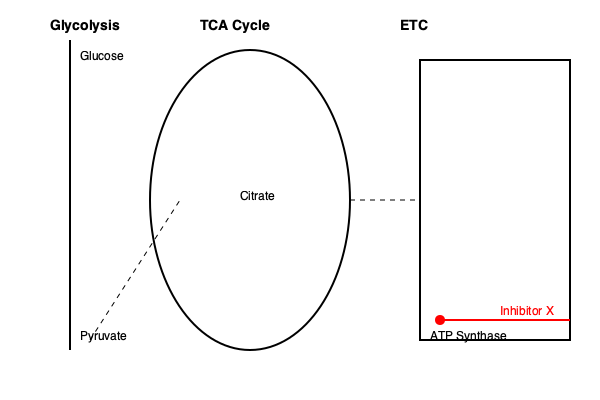In the metabolic pathway diagram, an inhibitor X is shown to affect a specific component. Given your expertise in disease mechanisms, explain how this inhibition might impact overall cellular energy production and propose a potential therapeutic strategy to counteract its effects. To understand the impact of inhibitor X and propose a therapeutic strategy, let's analyze the diagram step-by-step:

1. Pathway overview:
   - The diagram shows three main pathways: Glycolysis, TCA (Tricarboxylic Acid) Cycle, and ETC (Electron Transport Chain).
   - These pathways are interconnected and crucial for cellular energy production.

2. Inhibitor X's target:
   - The red line and circle indicate that inhibitor X is targeting ATP Synthase in the ETC.

3. Role of ATP Synthase:
   - ATP Synthase is the final enzyme complex in the ETC, responsible for synthesizing ATP through oxidative phosphorylation.
   - It utilizes the proton gradient generated by the ETC to produce ATP from ADP and inorganic phosphate.

4. Impact of inhibition:
   - Inhibiting ATP Synthase would significantly reduce ATP production through oxidative phosphorylation.
   - This would lead to a decrease in overall cellular energy production.
   - The proton gradient might build up excessively, potentially leading to mitochondrial dysfunction.

5. Cascade effects:
   - Reduced ATP production could affect various cellular processes dependent on ATP.
   - The TCA cycle might slow down due to feedback inhibition from accumulated NADH and FADH2.
   - Glycolysis might increase to compensate, leading to increased lactate production and potential acidosis.

6. Potential therapeutic strategies:
   a) Direct approach: Develop a competitive inhibitor that can displace inhibitor X from ATP Synthase.
   b) Bypass strategy: Enhance substrate-level phosphorylation in glycolysis and the TCA cycle to partially compensate for reduced oxidative phosphorylation.
   c) Alternative energy source: Introduce ketone bodies or fatty acids that can be metabolized to acetyl-CoA, bypassing glycolysis and entering the TCA cycle directly.
   d) Mitochondrial protection: Use antioxidants or mitochondria-targeted drugs to prevent further damage from potential reactive oxygen species accumulation.
   e) Gene therapy: Upregulate the expression of ATP Synthase to overcome the inhibition, or introduce a modified ATP Synthase resistant to inhibitor X.

The most promising approach would likely be a combination of these strategies, tailored to the specific disease context and patient condition.
Answer: Develop a competitive inhibitor for X, enhance substrate-level phosphorylation, introduce alternative energy sources, protect mitochondria, and consider gene therapy to upregulate or modify ATP Synthase. 